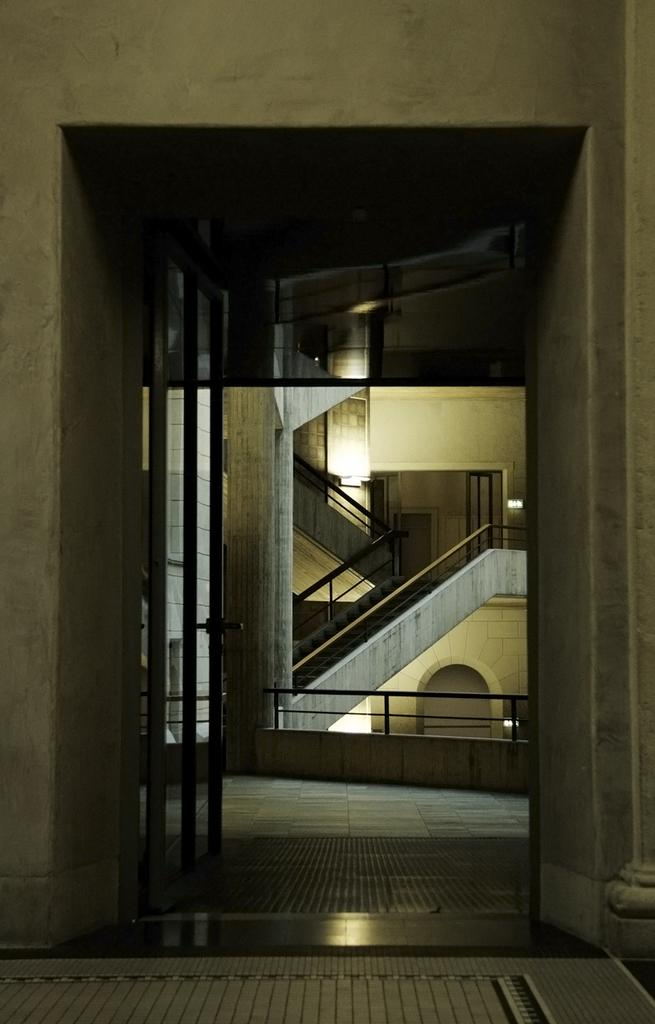What type of structure is visible in the image? There is a building in the image. What can be seen illuminating the building or its surroundings? There are lights in the image. How can one access different levels of the building? There are stairs in the image. What are the entry points to the building? There are doors in the image. What might be used to provide support or safety while using the stairs? There are staircase holders in the image. What decision does the goose make in the image? There is no goose present in the image, so no decision can be made by a goose. 